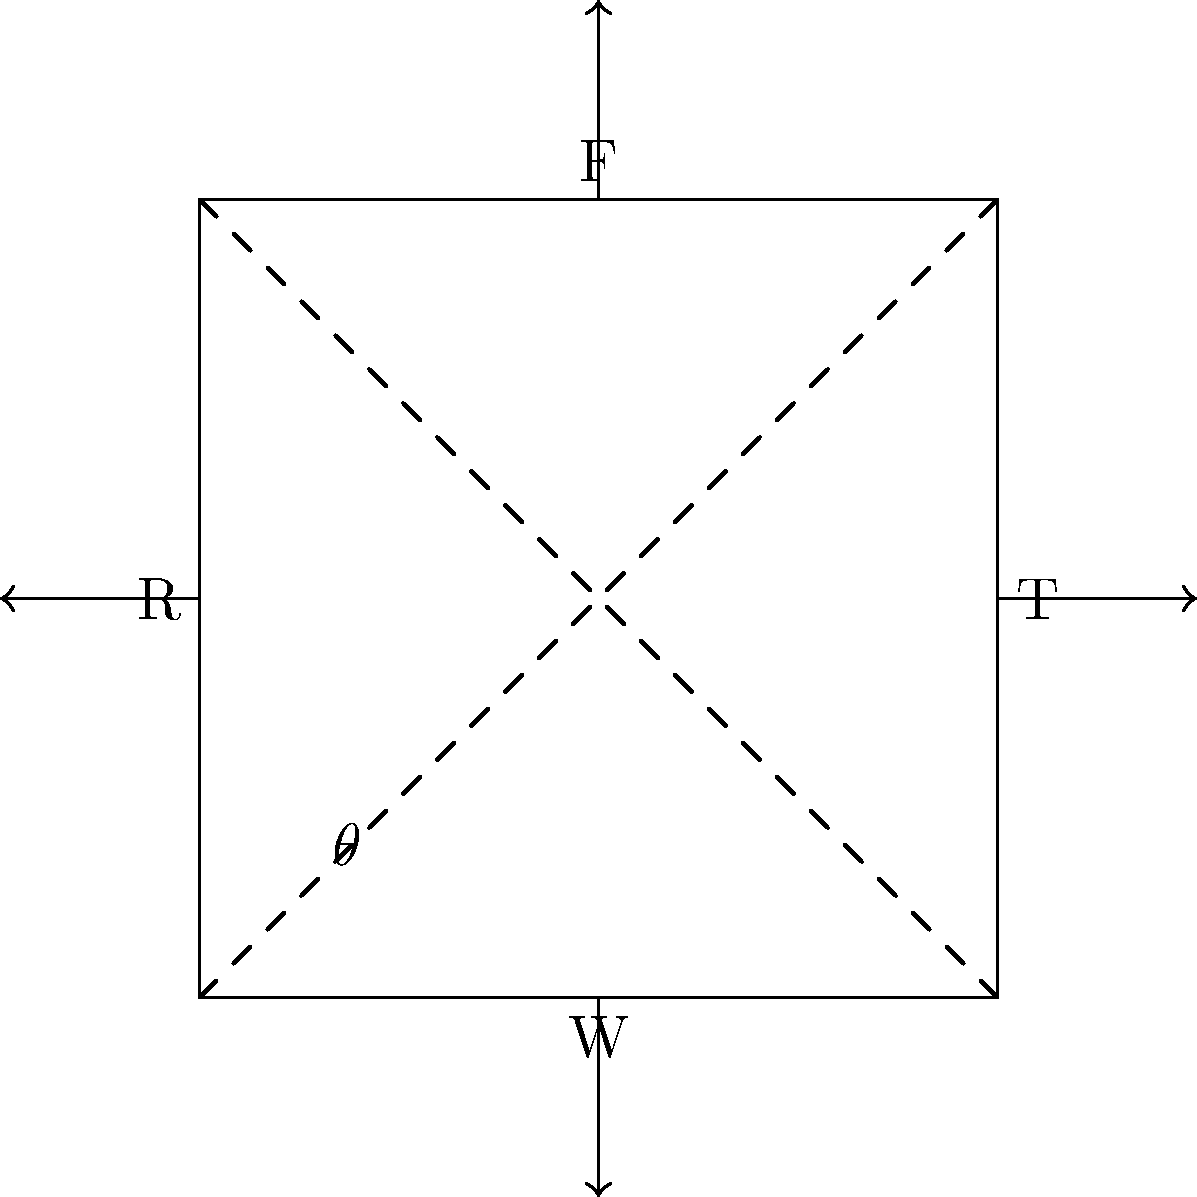In an industrial manufacturing process, a machine part is subjected to various forces as shown in the force diagram. The part experiences an applied force F from above, a reaction force R from the left, a tensile force T from the right, and its own weight W. If the angle between the diagonal of the part and its base is $\theta$, express the magnitude of the reaction force R in terms of F, T, W, and $\theta$ when the system is in equilibrium. To solve this problem, we'll follow these steps:

1. Identify the forces acting on the part:
   - Applied force F (upward)
   - Reaction force R (leftward)
   - Tensile force T (rightward)
   - Weight W (downward)

2. Apply the conditions for equilibrium:
   - Sum of forces in x-direction = 0
   - Sum of forces in y-direction = 0

3. Resolve forces into x and y components:
   - F has components: $F_x = -F \sin \theta$, $F_y = F \cos \theta$
   - R is already in x-direction: $R_x = -R$
   - T is already in x-direction: $T_x = T$
   - W is already in y-direction: $W_y = -W$

4. Write equations for equilibrium:
   x-direction: $-F \sin \theta - R + T = 0$
   y-direction: $F \cos \theta - W = 0$

5. Solve for R:
   From the x-direction equation:
   $R = T - F \sin \theta$

6. Express F in terms of W:
   From the y-direction equation:
   $F \cos \theta = W$
   $F = \frac{W}{\cos \theta}$

7. Substitute F into the equation for R:
   $R = T - \frac{W}{\cos \theta} \sin \theta$
   $R = T - W \tan \theta$

Therefore, the magnitude of the reaction force R can be expressed as $T - W \tan \theta$.
Answer: $R = T - W \tan \theta$ 